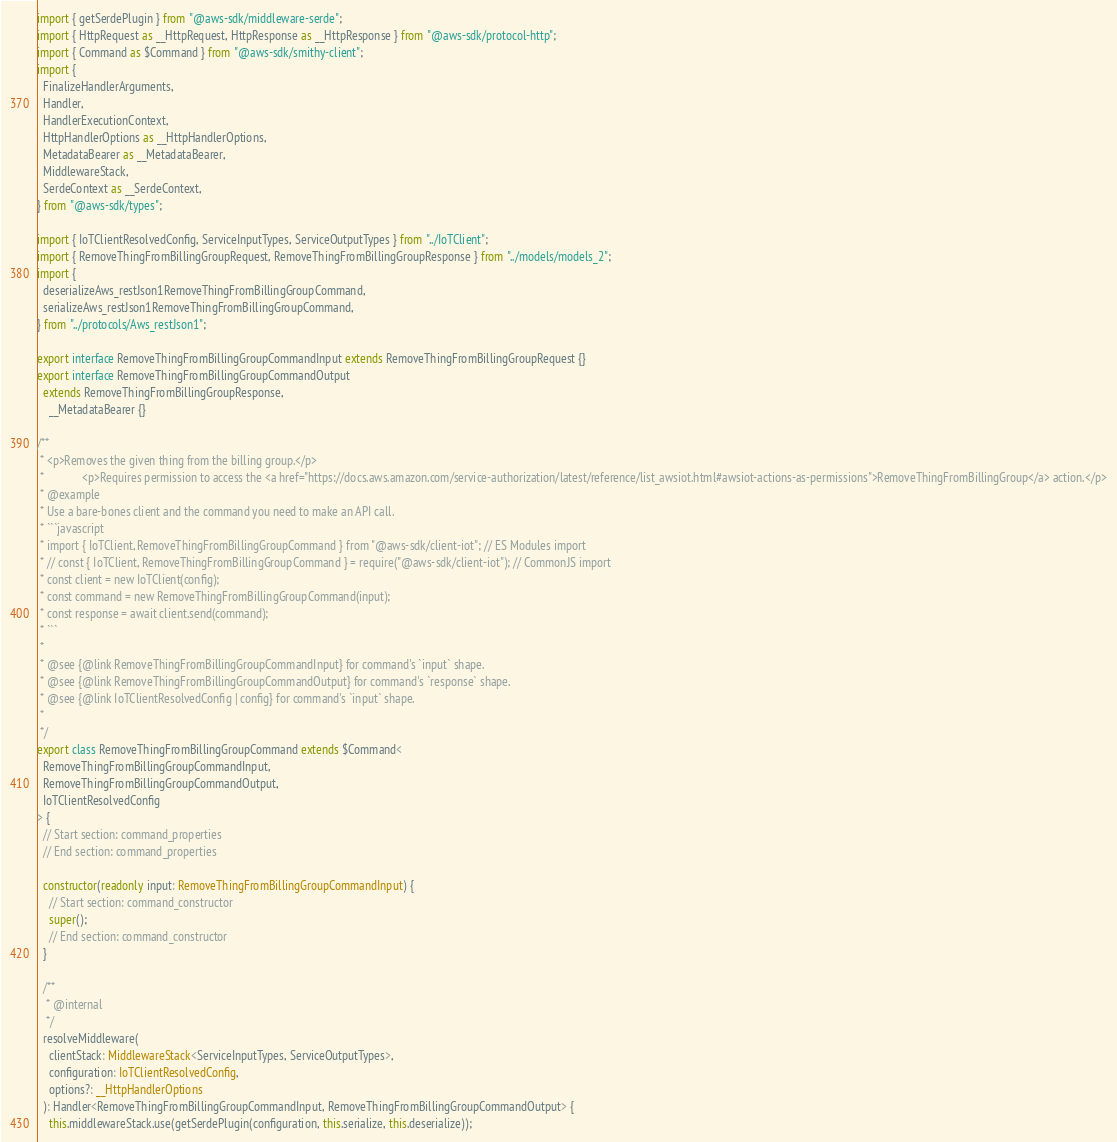<code> <loc_0><loc_0><loc_500><loc_500><_TypeScript_>import { getSerdePlugin } from "@aws-sdk/middleware-serde";
import { HttpRequest as __HttpRequest, HttpResponse as __HttpResponse } from "@aws-sdk/protocol-http";
import { Command as $Command } from "@aws-sdk/smithy-client";
import {
  FinalizeHandlerArguments,
  Handler,
  HandlerExecutionContext,
  HttpHandlerOptions as __HttpHandlerOptions,
  MetadataBearer as __MetadataBearer,
  MiddlewareStack,
  SerdeContext as __SerdeContext,
} from "@aws-sdk/types";

import { IoTClientResolvedConfig, ServiceInputTypes, ServiceOutputTypes } from "../IoTClient";
import { RemoveThingFromBillingGroupRequest, RemoveThingFromBillingGroupResponse } from "../models/models_2";
import {
  deserializeAws_restJson1RemoveThingFromBillingGroupCommand,
  serializeAws_restJson1RemoveThingFromBillingGroupCommand,
} from "../protocols/Aws_restJson1";

export interface RemoveThingFromBillingGroupCommandInput extends RemoveThingFromBillingGroupRequest {}
export interface RemoveThingFromBillingGroupCommandOutput
  extends RemoveThingFromBillingGroupResponse,
    __MetadataBearer {}

/**
 * <p>Removes the given thing from the billing group.</p>
 * 		       <p>Requires permission to access the <a href="https://docs.aws.amazon.com/service-authorization/latest/reference/list_awsiot.html#awsiot-actions-as-permissions">RemoveThingFromBillingGroup</a> action.</p>
 * @example
 * Use a bare-bones client and the command you need to make an API call.
 * ```javascript
 * import { IoTClient, RemoveThingFromBillingGroupCommand } from "@aws-sdk/client-iot"; // ES Modules import
 * // const { IoTClient, RemoveThingFromBillingGroupCommand } = require("@aws-sdk/client-iot"); // CommonJS import
 * const client = new IoTClient(config);
 * const command = new RemoveThingFromBillingGroupCommand(input);
 * const response = await client.send(command);
 * ```
 *
 * @see {@link RemoveThingFromBillingGroupCommandInput} for command's `input` shape.
 * @see {@link RemoveThingFromBillingGroupCommandOutput} for command's `response` shape.
 * @see {@link IoTClientResolvedConfig | config} for command's `input` shape.
 *
 */
export class RemoveThingFromBillingGroupCommand extends $Command<
  RemoveThingFromBillingGroupCommandInput,
  RemoveThingFromBillingGroupCommandOutput,
  IoTClientResolvedConfig
> {
  // Start section: command_properties
  // End section: command_properties

  constructor(readonly input: RemoveThingFromBillingGroupCommandInput) {
    // Start section: command_constructor
    super();
    // End section: command_constructor
  }

  /**
   * @internal
   */
  resolveMiddleware(
    clientStack: MiddlewareStack<ServiceInputTypes, ServiceOutputTypes>,
    configuration: IoTClientResolvedConfig,
    options?: __HttpHandlerOptions
  ): Handler<RemoveThingFromBillingGroupCommandInput, RemoveThingFromBillingGroupCommandOutput> {
    this.middlewareStack.use(getSerdePlugin(configuration, this.serialize, this.deserialize));
</code> 